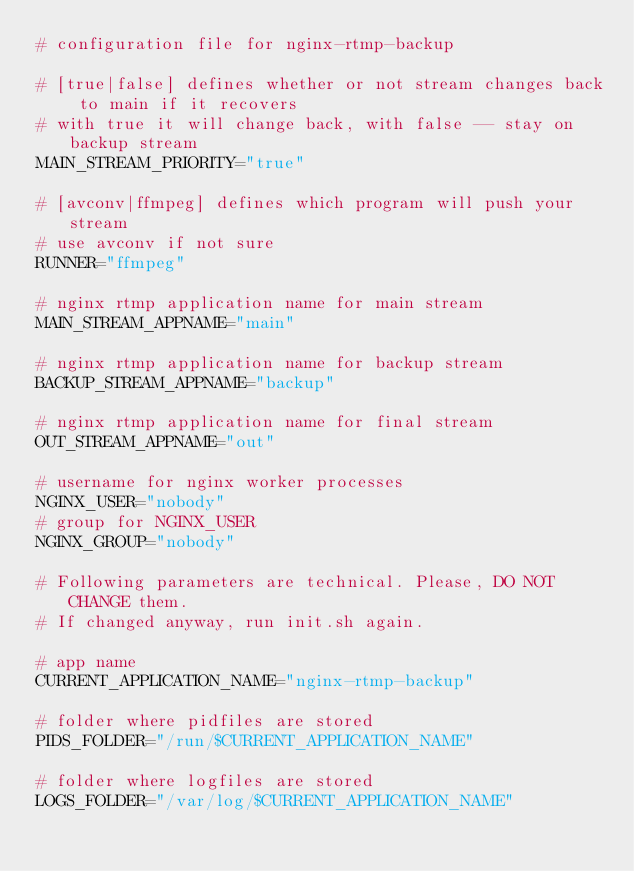Convert code to text. <code><loc_0><loc_0><loc_500><loc_500><_Bash_># configuration file for nginx-rtmp-backup

# [true|false] defines whether or not stream changes back to main if it recovers
# with true it will change back, with false -- stay on backup stream
MAIN_STREAM_PRIORITY="true"

# [avconv|ffmpeg] defines which program will push your stream
# use avconv if not sure
RUNNER="ffmpeg"

# nginx rtmp application name for main stream
MAIN_STREAM_APPNAME="main"

# nginx rtmp application name for backup stream
BACKUP_STREAM_APPNAME="backup"

# nginx rtmp application name for final stream
OUT_STREAM_APPNAME="out"

# username for nginx worker processes
NGINX_USER="nobody"
# group for NGINX_USER
NGINX_GROUP="nobody"

# Following parameters are technical. Please, DO NOT CHANGE them.
# If changed anyway, run init.sh again.

# app name
CURRENT_APPLICATION_NAME="nginx-rtmp-backup"

# folder where pidfiles are stored
PIDS_FOLDER="/run/$CURRENT_APPLICATION_NAME"

# folder where logfiles are stored
LOGS_FOLDER="/var/log/$CURRENT_APPLICATION_NAME"
</code> 